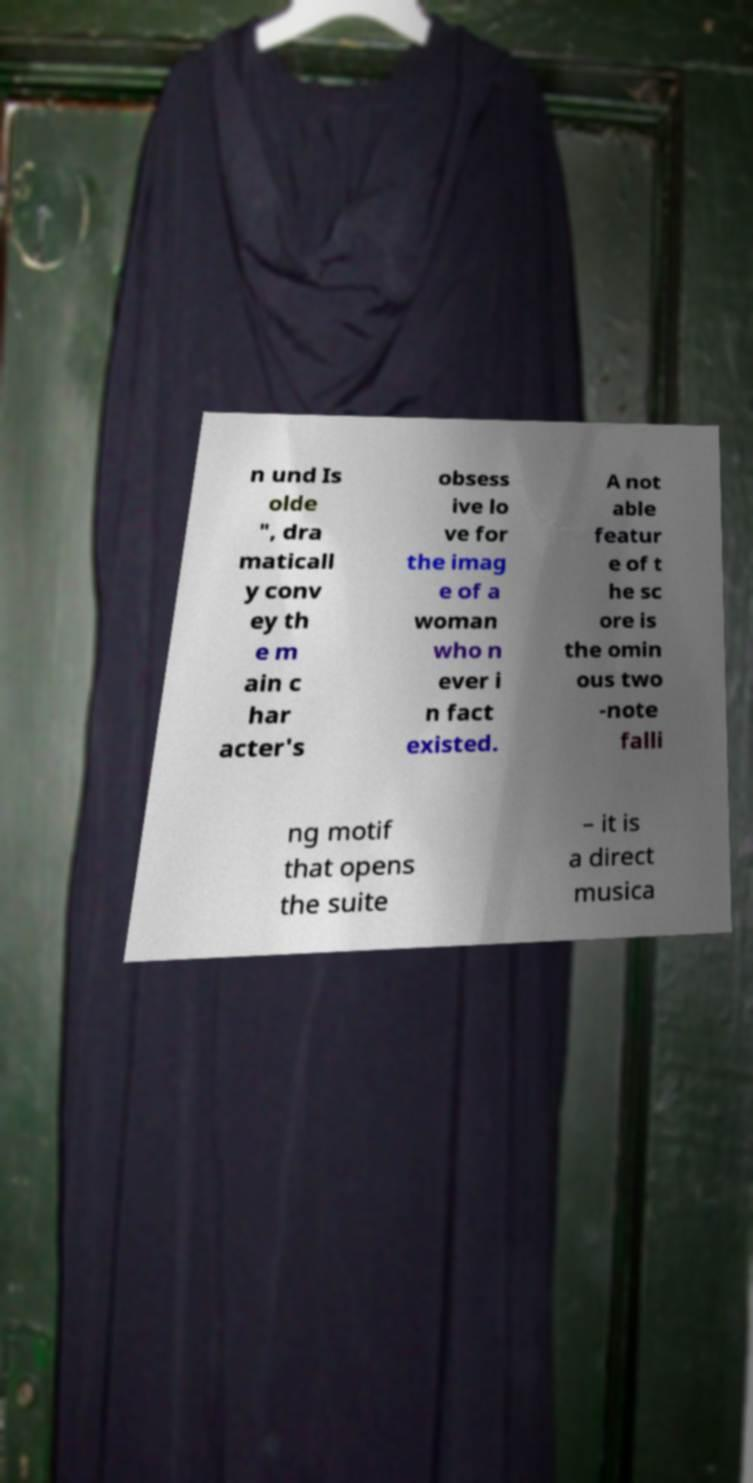What messages or text are displayed in this image? I need them in a readable, typed format. n und Is olde ", dra maticall y conv ey th e m ain c har acter's obsess ive lo ve for the imag e of a woman who n ever i n fact existed. A not able featur e of t he sc ore is the omin ous two -note falli ng motif that opens the suite – it is a direct musica 